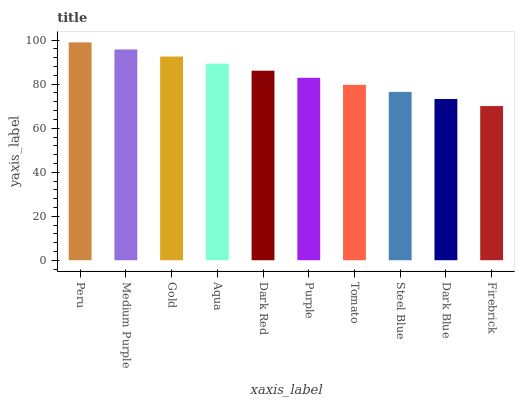Is Firebrick the minimum?
Answer yes or no. Yes. Is Peru the maximum?
Answer yes or no. Yes. Is Medium Purple the minimum?
Answer yes or no. No. Is Medium Purple the maximum?
Answer yes or no. No. Is Peru greater than Medium Purple?
Answer yes or no. Yes. Is Medium Purple less than Peru?
Answer yes or no. Yes. Is Medium Purple greater than Peru?
Answer yes or no. No. Is Peru less than Medium Purple?
Answer yes or no. No. Is Dark Red the high median?
Answer yes or no. Yes. Is Purple the low median?
Answer yes or no. Yes. Is Firebrick the high median?
Answer yes or no. No. Is Tomato the low median?
Answer yes or no. No. 